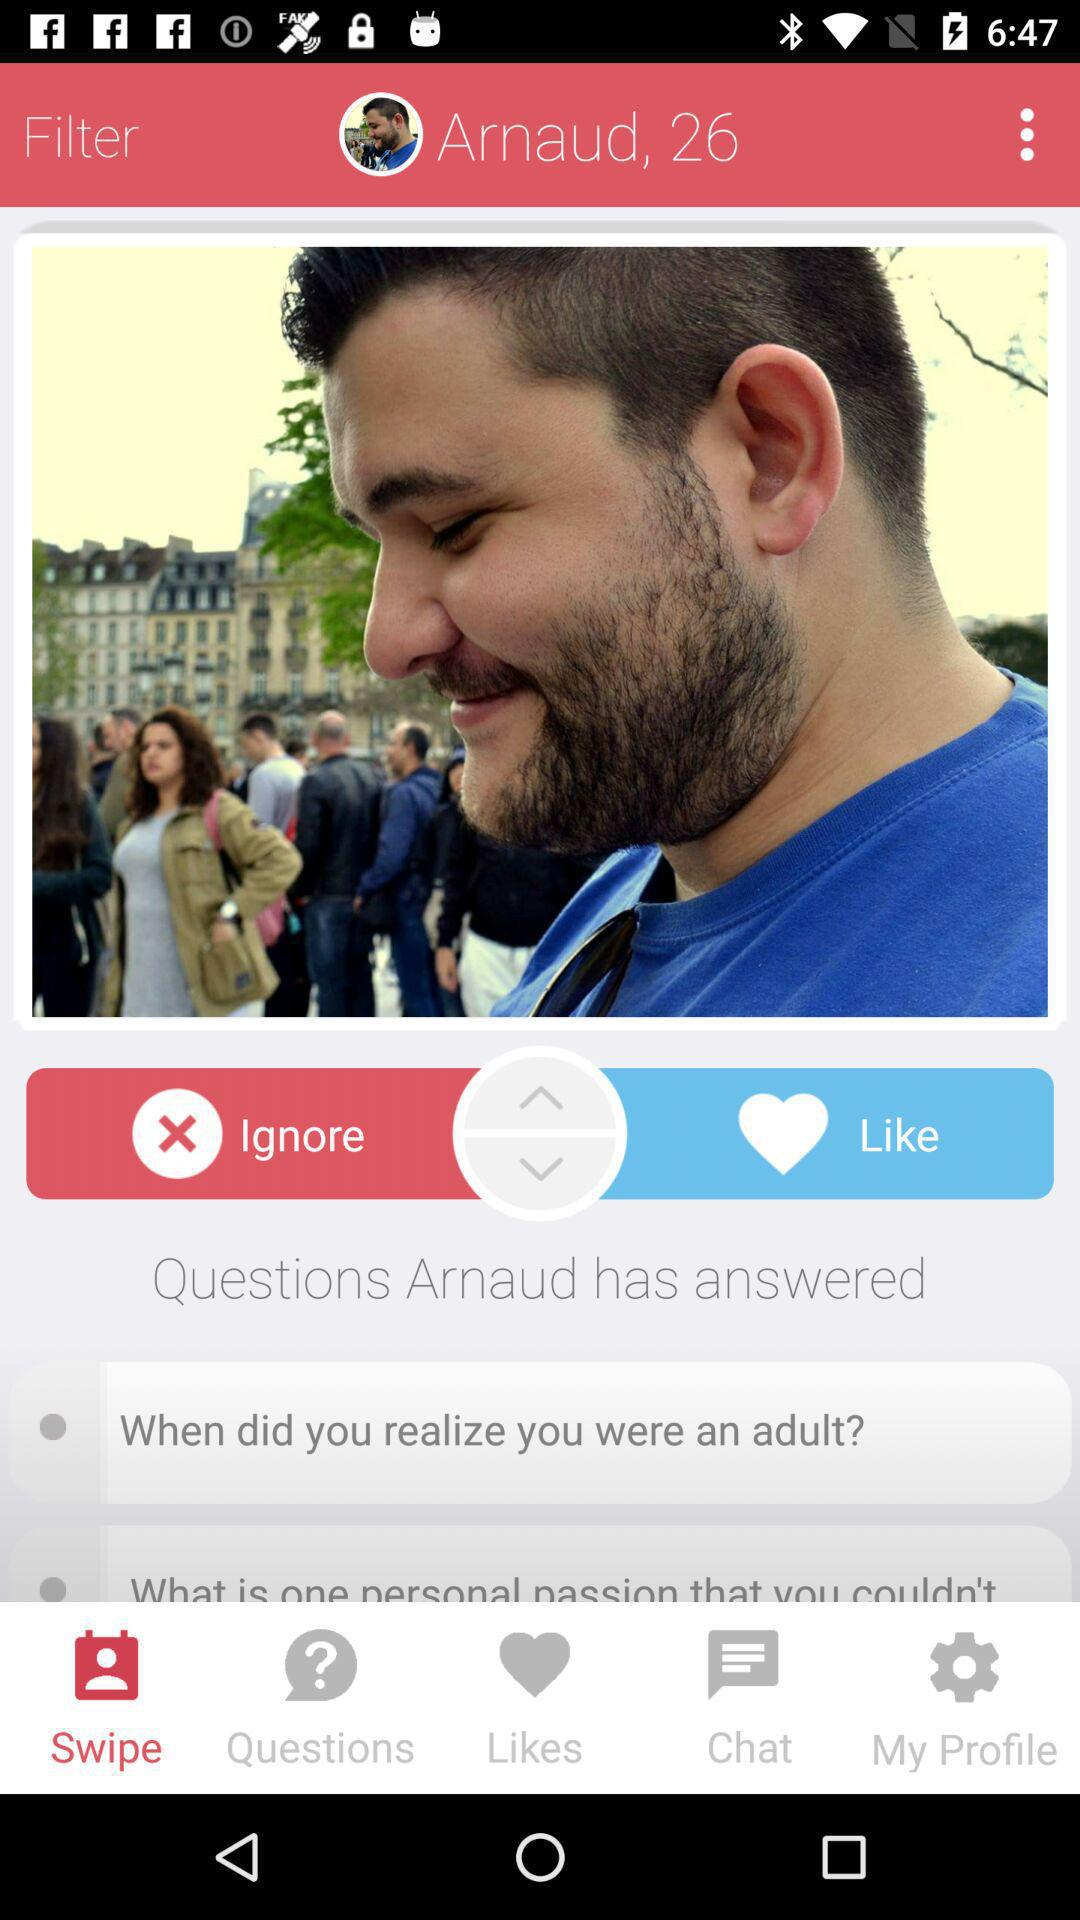How many questions has Arnaud answered?
Answer the question using a single word or phrase. 2 